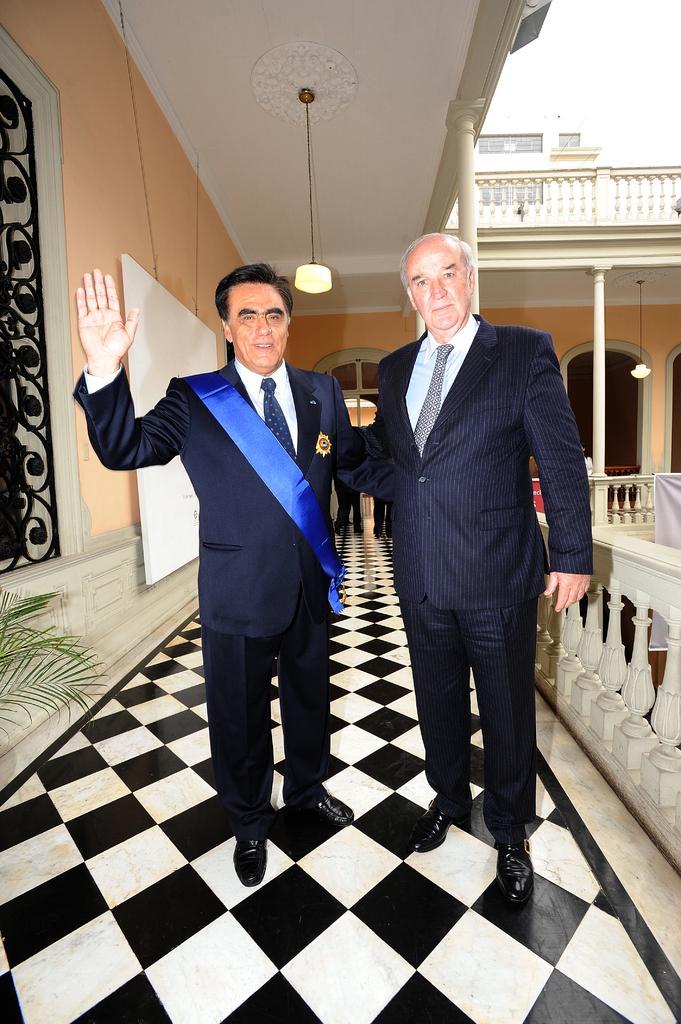Could you give a brief overview of what you see in this image? In this picture I can see two persons standing, a person with a sash, there is a plant, board, banner, lights, pillars, there are two persons standing, and there is a building. 